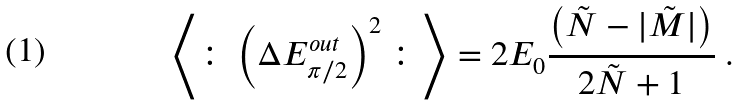Convert formula to latex. <formula><loc_0><loc_0><loc_500><loc_500>\left \langle \colon \left ( \Delta E ^ { o u t } _ { \pi / 2 } \right ) ^ { 2 } \colon \right \rangle = 2 E _ { 0 } \frac { \left ( \tilde { N } - | \tilde { M } | \right ) } { 2 \tilde { N } + 1 } \ .</formula> 